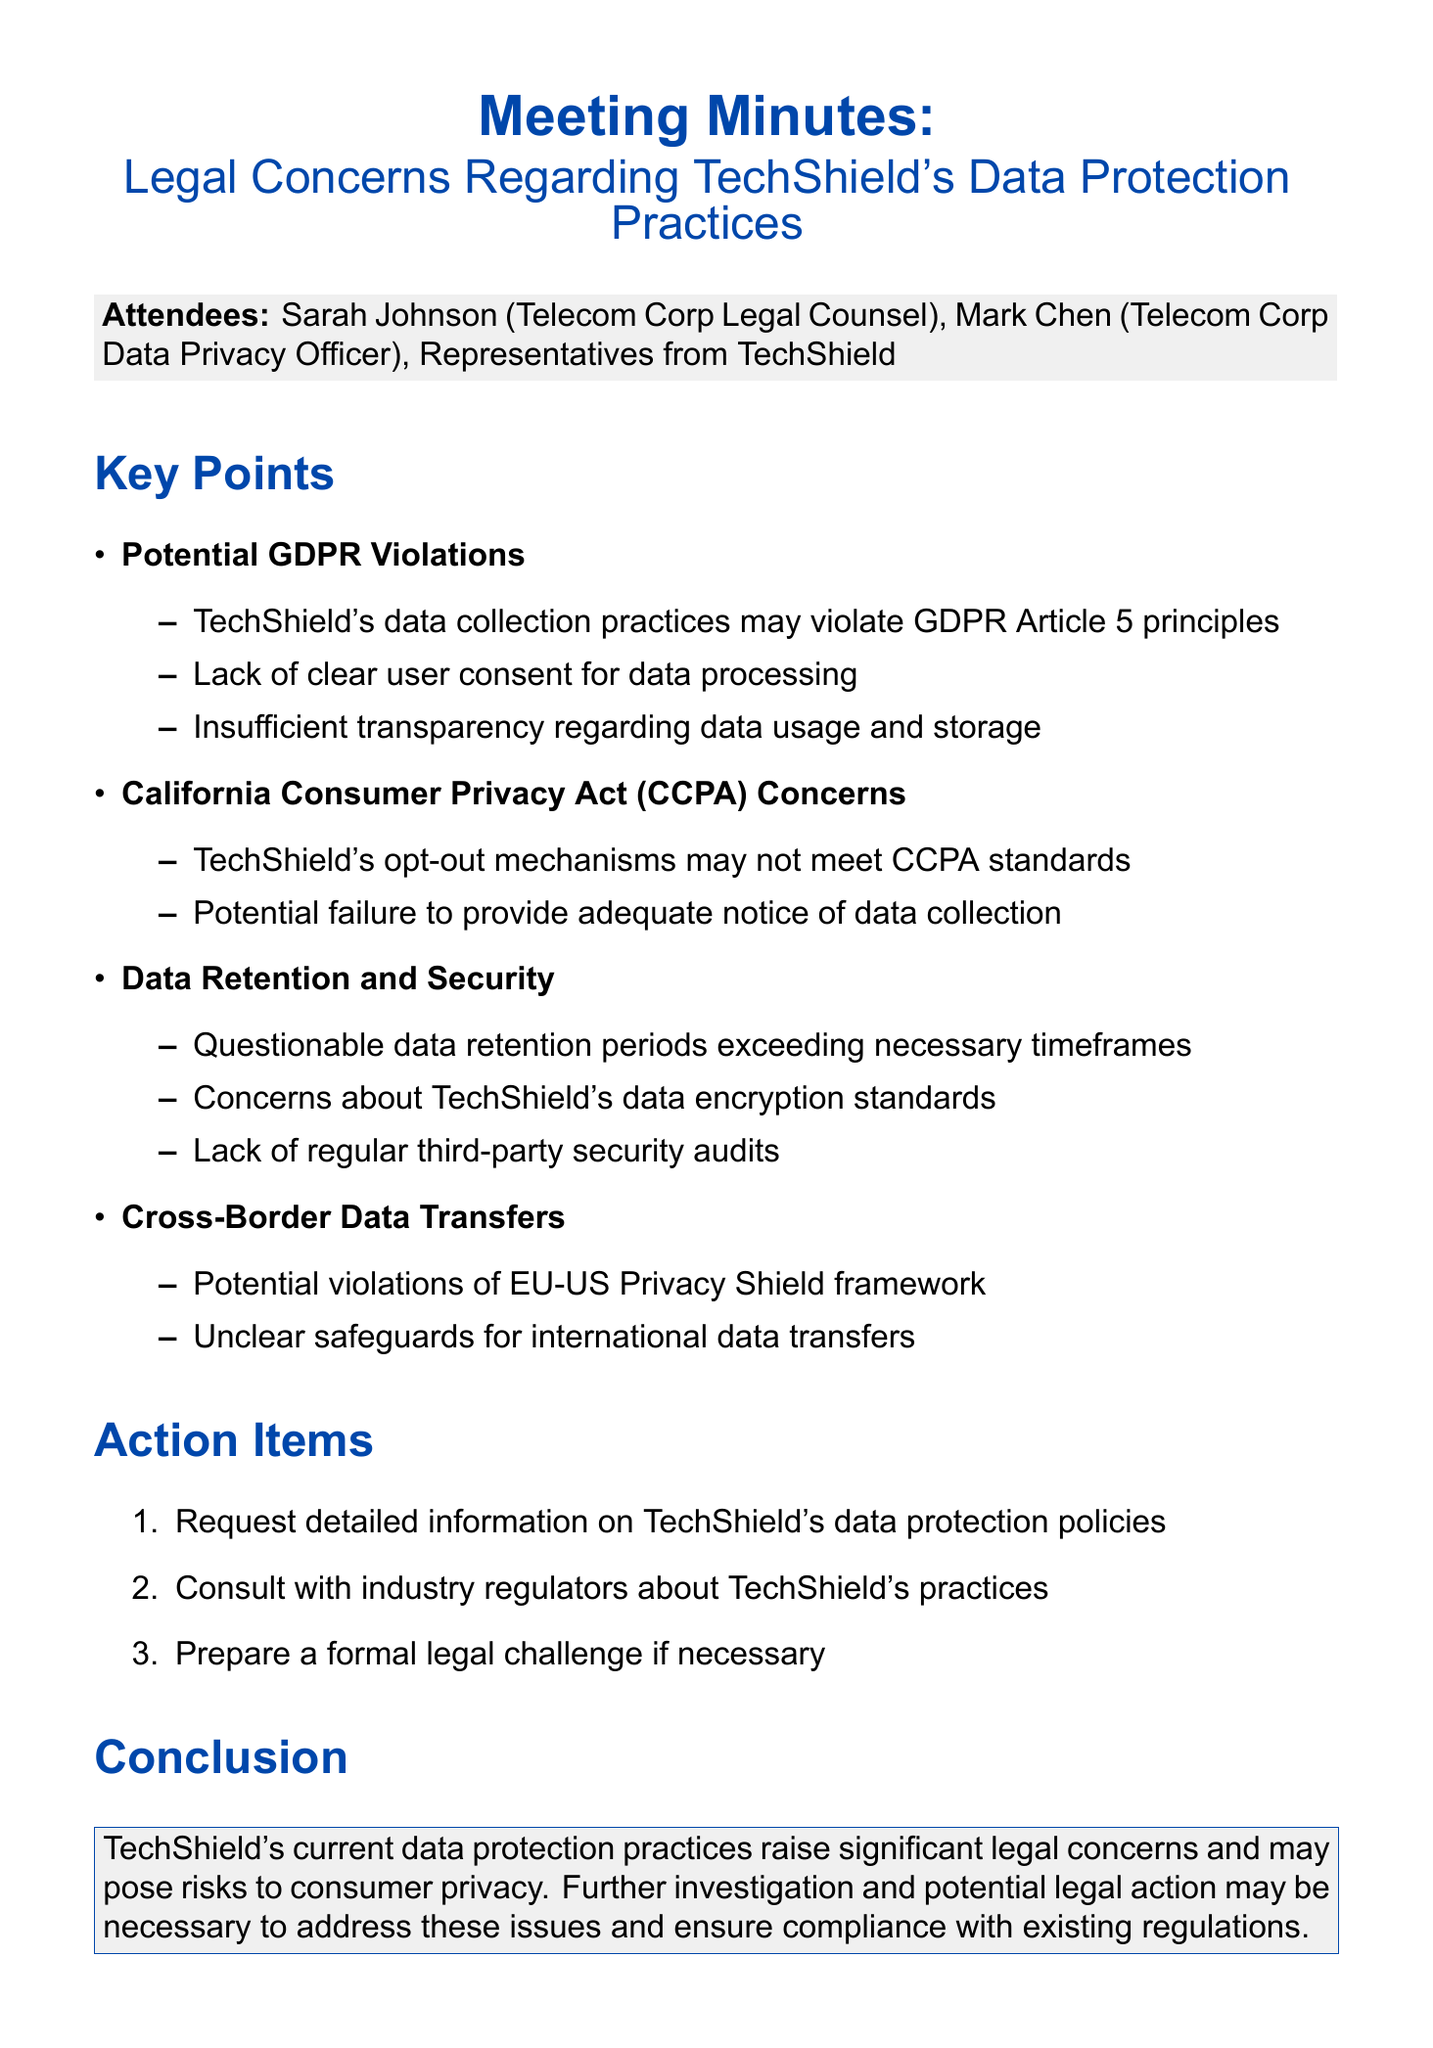What are the names of the attendees? The names of the attendees include Sarah Johnson, Mark Chen, and representatives from TechShield.
Answer: Sarah Johnson, Mark Chen, representatives from TechShield What is the main subject of the meeting? The main subject of the meeting is indicated in the title, which discusses legal concerns regarding TechShield's data protection practices.
Answer: Legal Concerns Regarding TechShield's Data Protection Practices What GDPR principle is potentially being violated? The document mentions that TechShield's data collection practices may violate GDPR Article 5 principles.
Answer: Article 5 What California regulation is referenced? The meeting discusses concerns related to the California Consumer Privacy Act.
Answer: CCPA What is one action item listed in the minutes? An action item listed is to request detailed information on TechShield's data protection policies.
Answer: Request detailed information on TechShield's data protection policies How many key points were discussed in the meeting? The document lists four key points regarding TechShield's data protection practices.
Answer: Four What aspect of data security is specifically questioned? The minutes raise concerns about TechShield's data encryption standards.
Answer: Data encryption standards Which framework is mentioned regarding cross-border data transfers? The EU-US Privacy Shield framework is mentioned in the context of potential violations.
Answer: EU-US Privacy Shield What conclusion is drawn about TechShield's practices? The conclusion states that TechShield's practices raise significant legal concerns and may pose risks to consumer privacy.
Answer: Significant legal concerns and risks to consumer privacy 